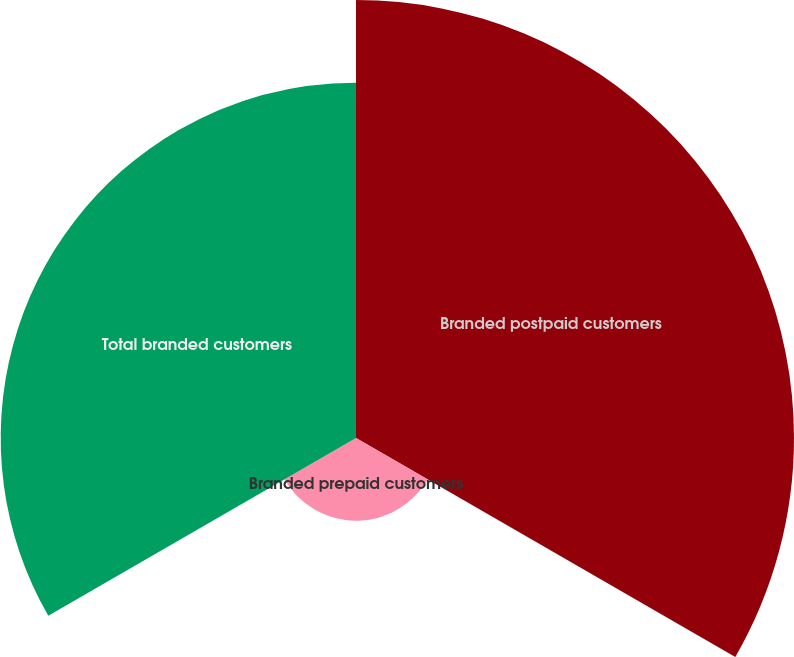<chart> <loc_0><loc_0><loc_500><loc_500><pie_chart><fcel>Branded postpaid customers<fcel>Branded prepaid customers<fcel>Total branded customers<nl><fcel>50.0%<fcel>9.44%<fcel>40.56%<nl></chart> 